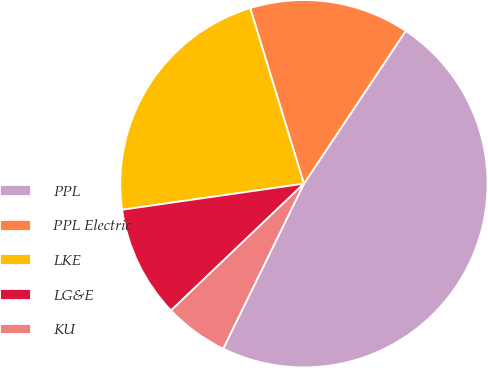Convert chart to OTSL. <chart><loc_0><loc_0><loc_500><loc_500><pie_chart><fcel>PPL<fcel>PPL Electric<fcel>LKE<fcel>LG&E<fcel>KU<nl><fcel>47.89%<fcel>14.08%<fcel>22.54%<fcel>9.86%<fcel>5.63%<nl></chart> 